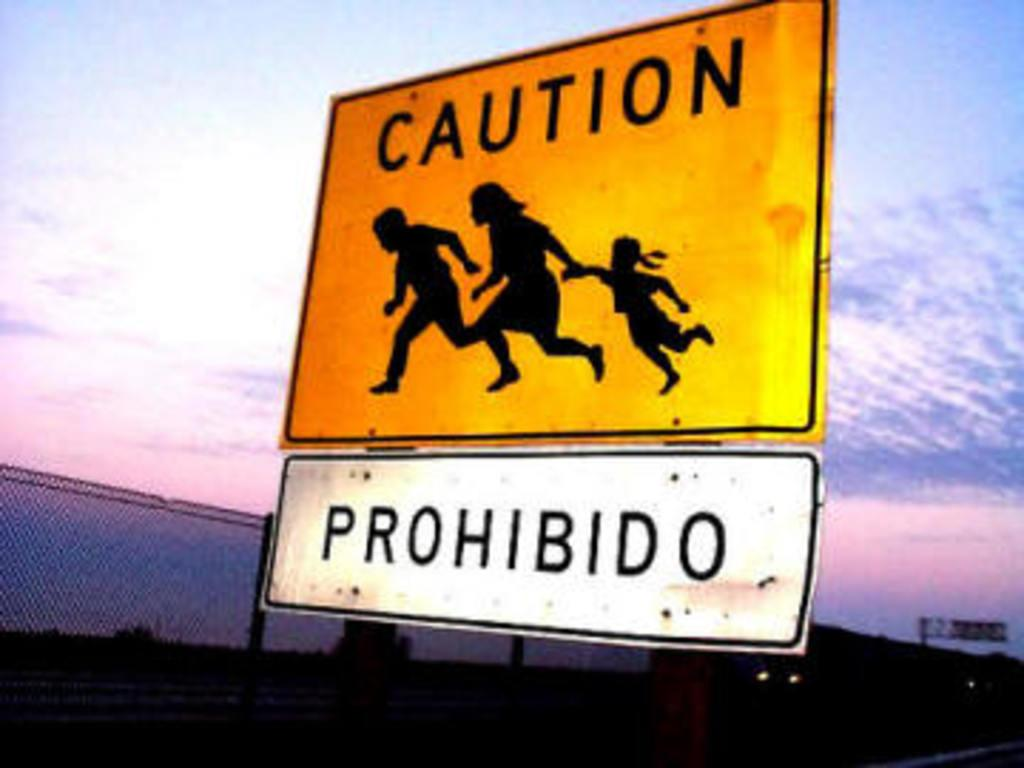Provide a one-sentence caption for the provided image. A road sign partially in Spanish cautions families to be careful. 